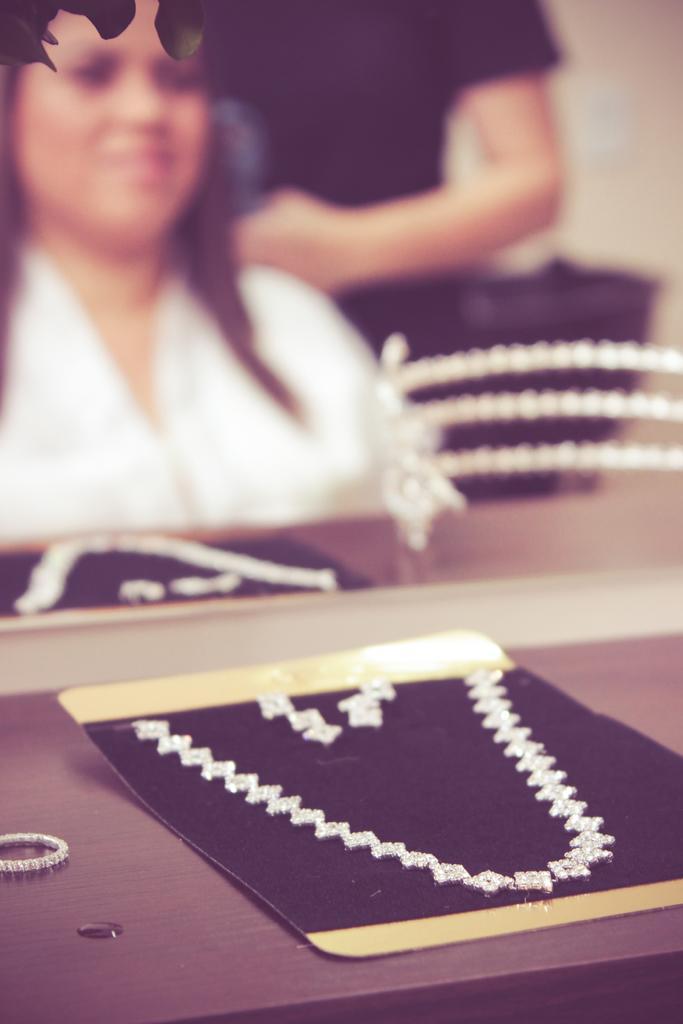In one or two sentences, can you explain what this image depicts? in this image we can see a jewelry piece kept on a surface, behind mirror is there. In mirror one lady reflection is there, she is wearing white color dress. Behind her one more person is standing. 